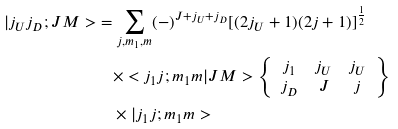Convert formula to latex. <formula><loc_0><loc_0><loc_500><loc_500>| j _ { U } j _ { D } ; J M > & = \sum _ { j , m _ { 1 } , m } ( - ) ^ { J + j _ { U } + j _ { D } } [ ( 2 j _ { U } + 1 ) ( 2 j + 1 ) ] ^ { \frac { 1 } { 2 } } \\ & \quad \times < j _ { 1 } j ; m _ { 1 } m | J M > \left \{ \begin{array} { c c c } j _ { 1 } & j _ { U } & j _ { U } \\ j _ { D } & J & j \end{array} \right \} \\ & \quad \times | j _ { 1 } j ; m _ { 1 } m ></formula> 